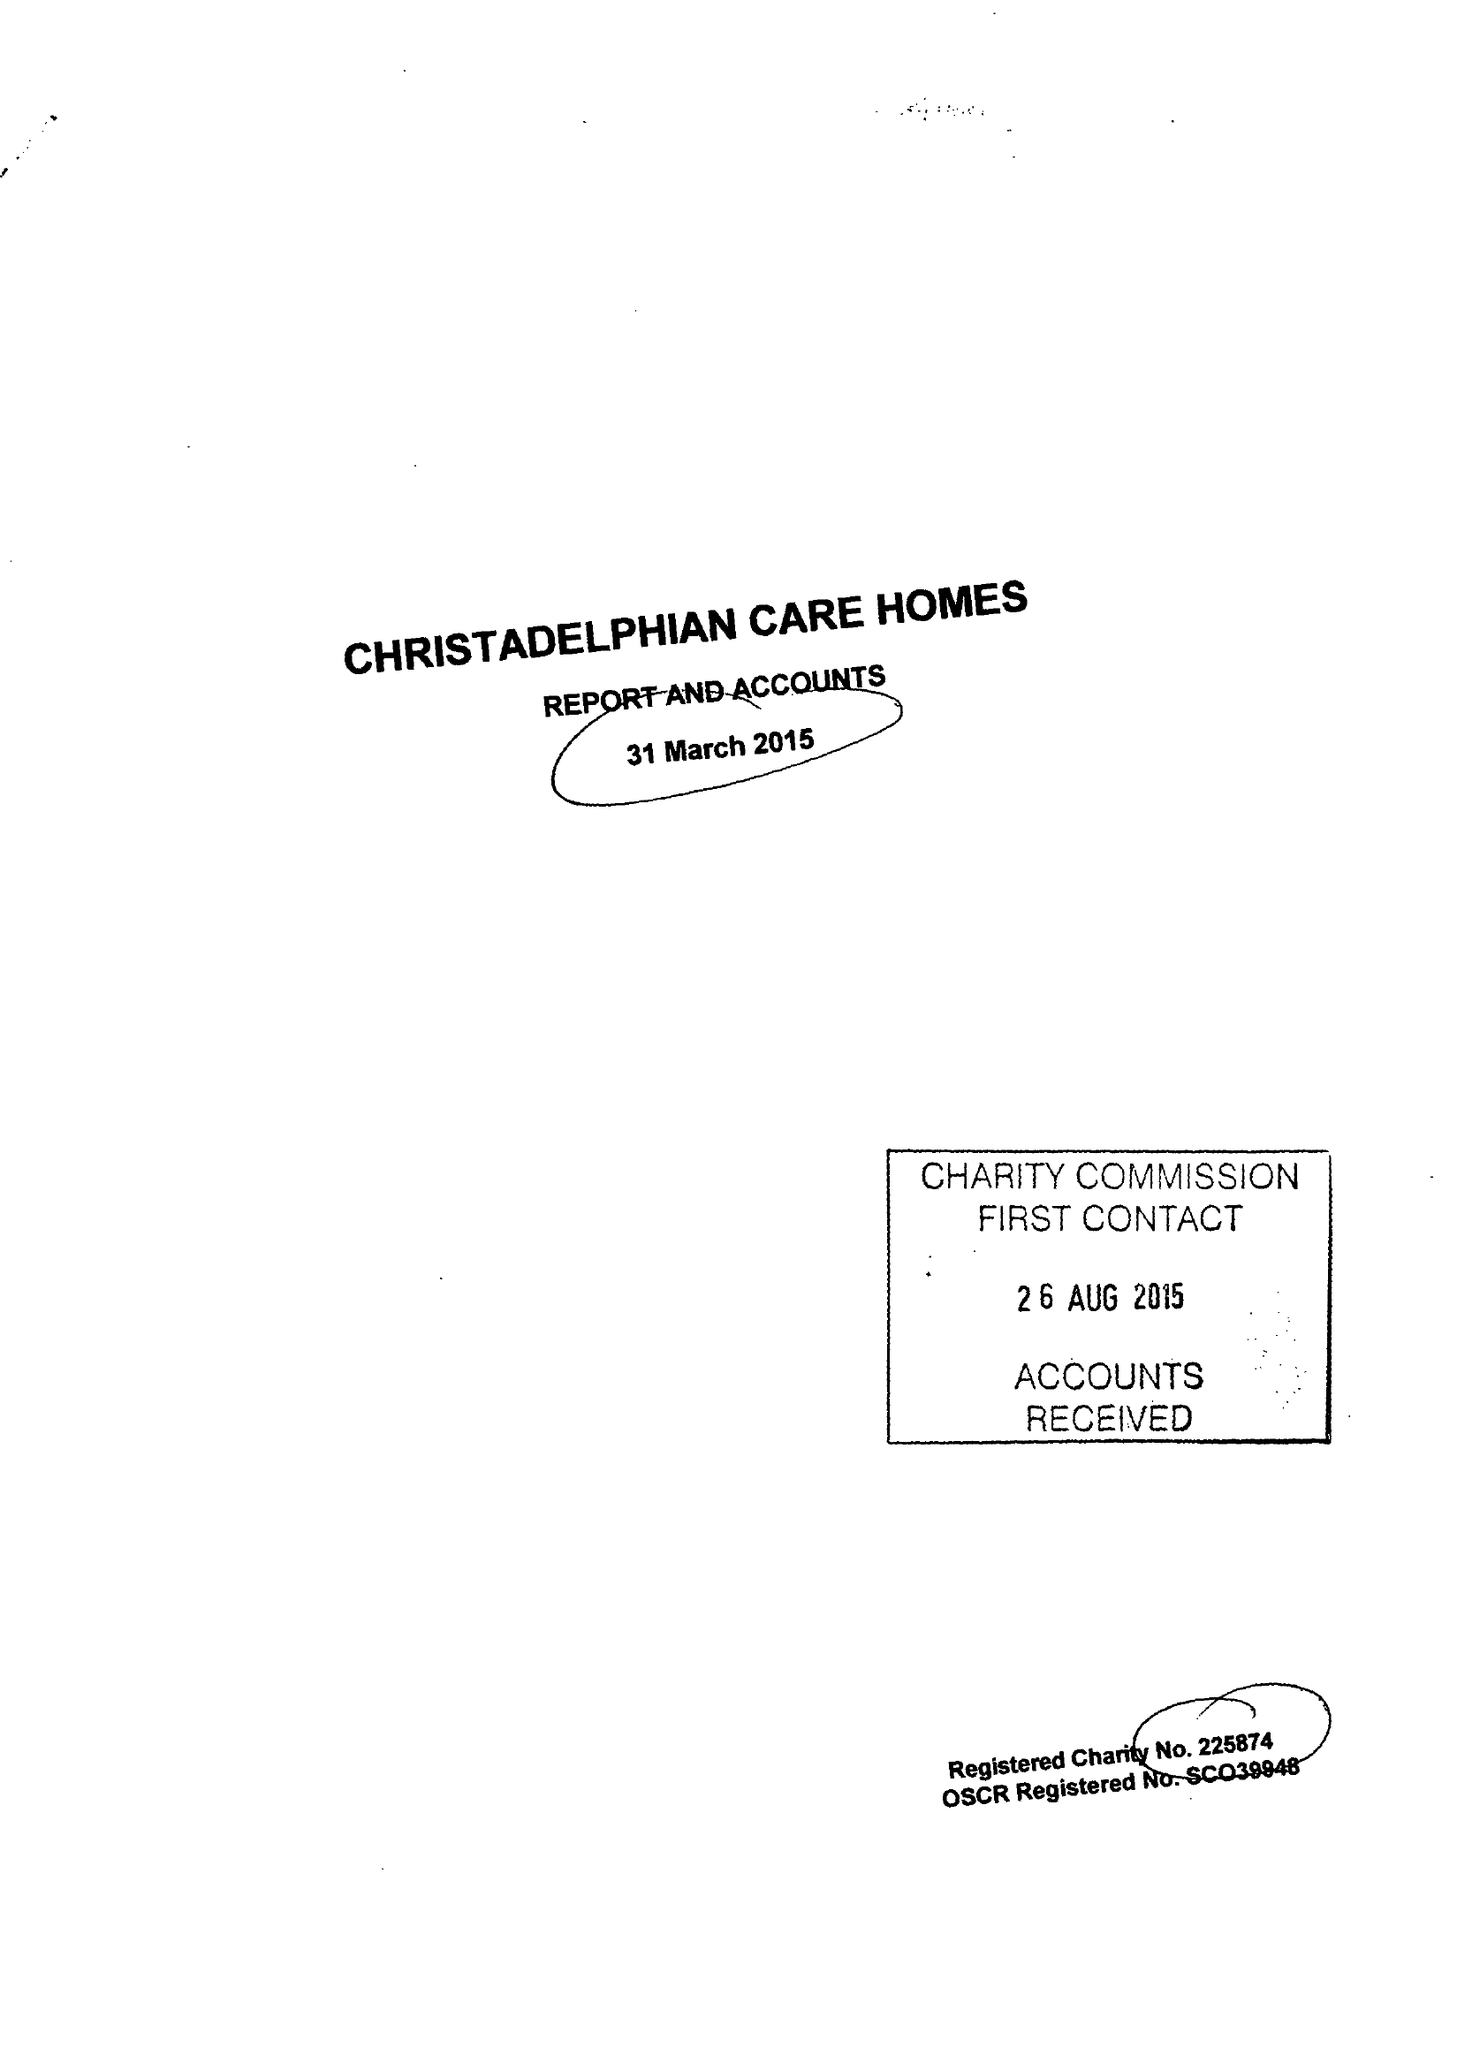What is the value for the charity_number?
Answer the question using a single word or phrase. 225874 